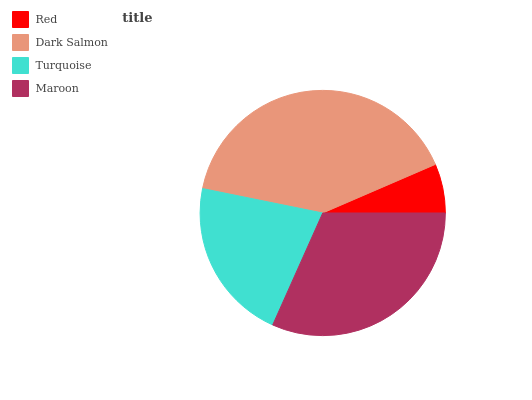Is Red the minimum?
Answer yes or no. Yes. Is Dark Salmon the maximum?
Answer yes or no. Yes. Is Turquoise the minimum?
Answer yes or no. No. Is Turquoise the maximum?
Answer yes or no. No. Is Dark Salmon greater than Turquoise?
Answer yes or no. Yes. Is Turquoise less than Dark Salmon?
Answer yes or no. Yes. Is Turquoise greater than Dark Salmon?
Answer yes or no. No. Is Dark Salmon less than Turquoise?
Answer yes or no. No. Is Maroon the high median?
Answer yes or no. Yes. Is Turquoise the low median?
Answer yes or no. Yes. Is Red the high median?
Answer yes or no. No. Is Maroon the low median?
Answer yes or no. No. 